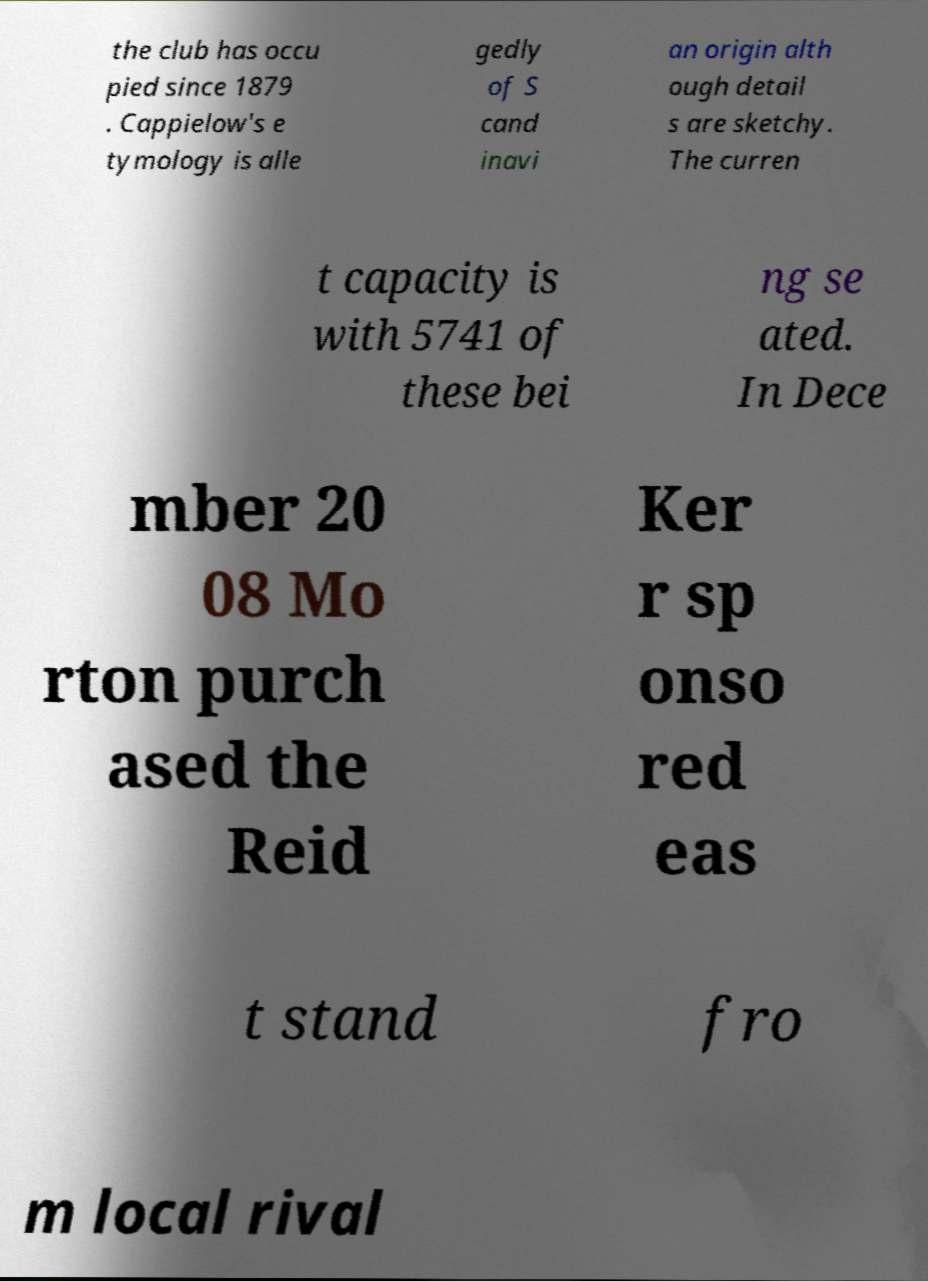There's text embedded in this image that I need extracted. Can you transcribe it verbatim? the club has occu pied since 1879 . Cappielow's e tymology is alle gedly of S cand inavi an origin alth ough detail s are sketchy. The curren t capacity is with 5741 of these bei ng se ated. In Dece mber 20 08 Mo rton purch ased the Reid Ker r sp onso red eas t stand fro m local rival 